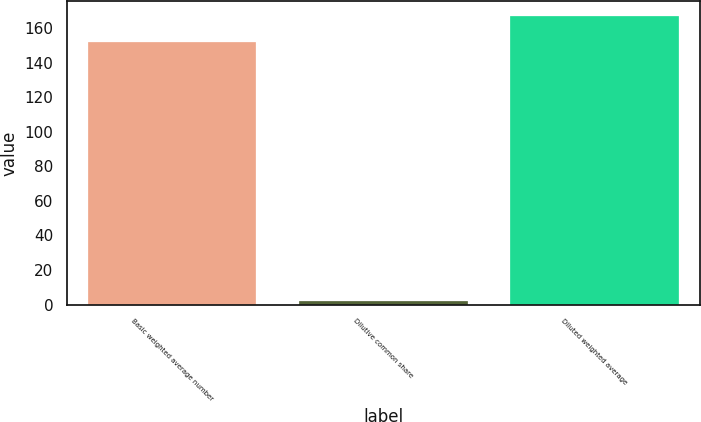Convert chart to OTSL. <chart><loc_0><loc_0><loc_500><loc_500><bar_chart><fcel>Basic weighted average number<fcel>Dilutive common share<fcel>Diluted weighted average<nl><fcel>152<fcel>2<fcel>167.2<nl></chart> 